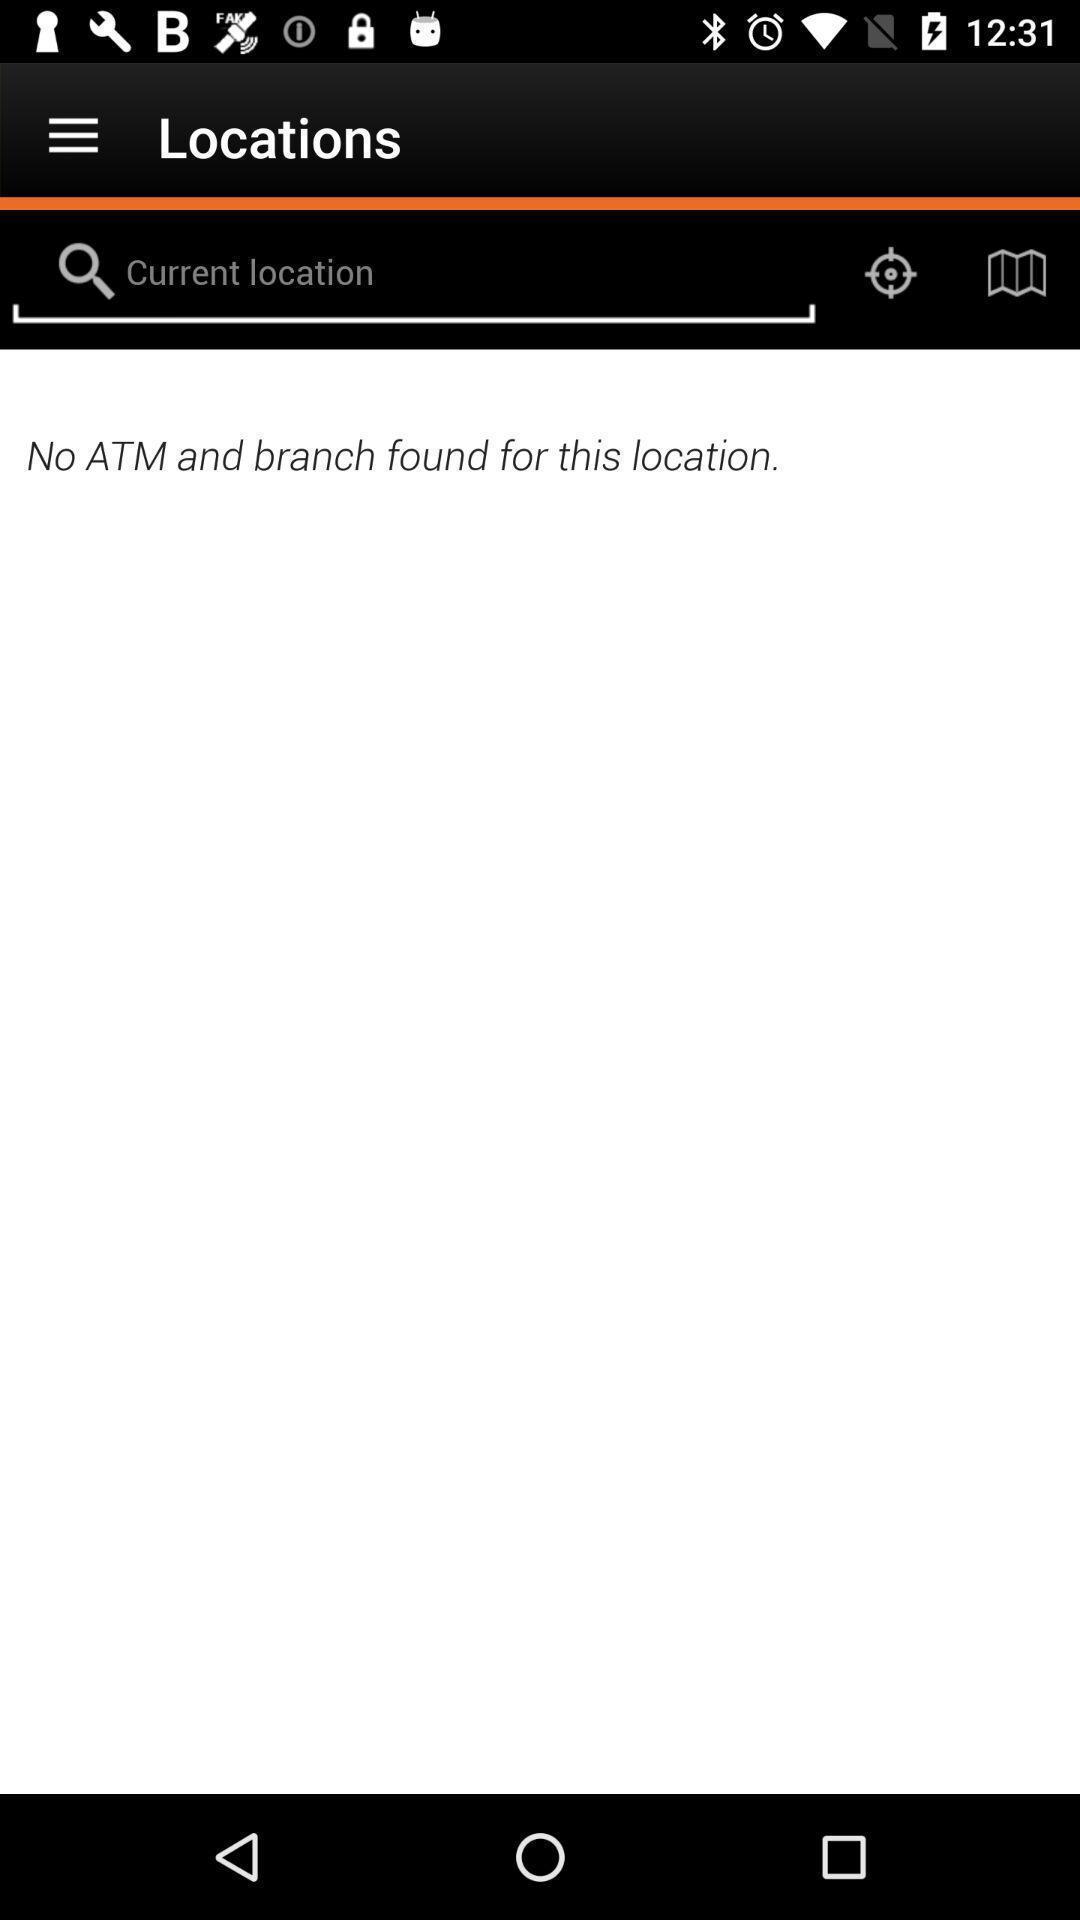Give me a summary of this screen capture. Search page to find the location with different options. 